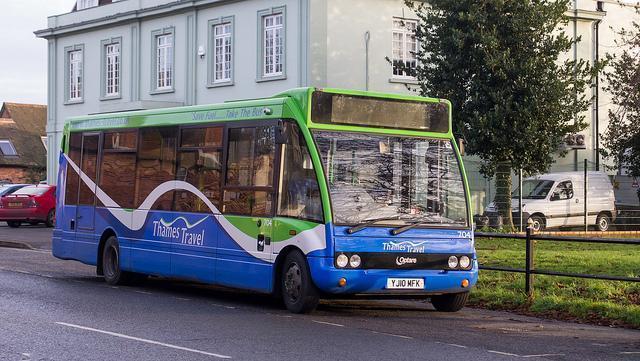How many people are wearing red?
Give a very brief answer. 0. 